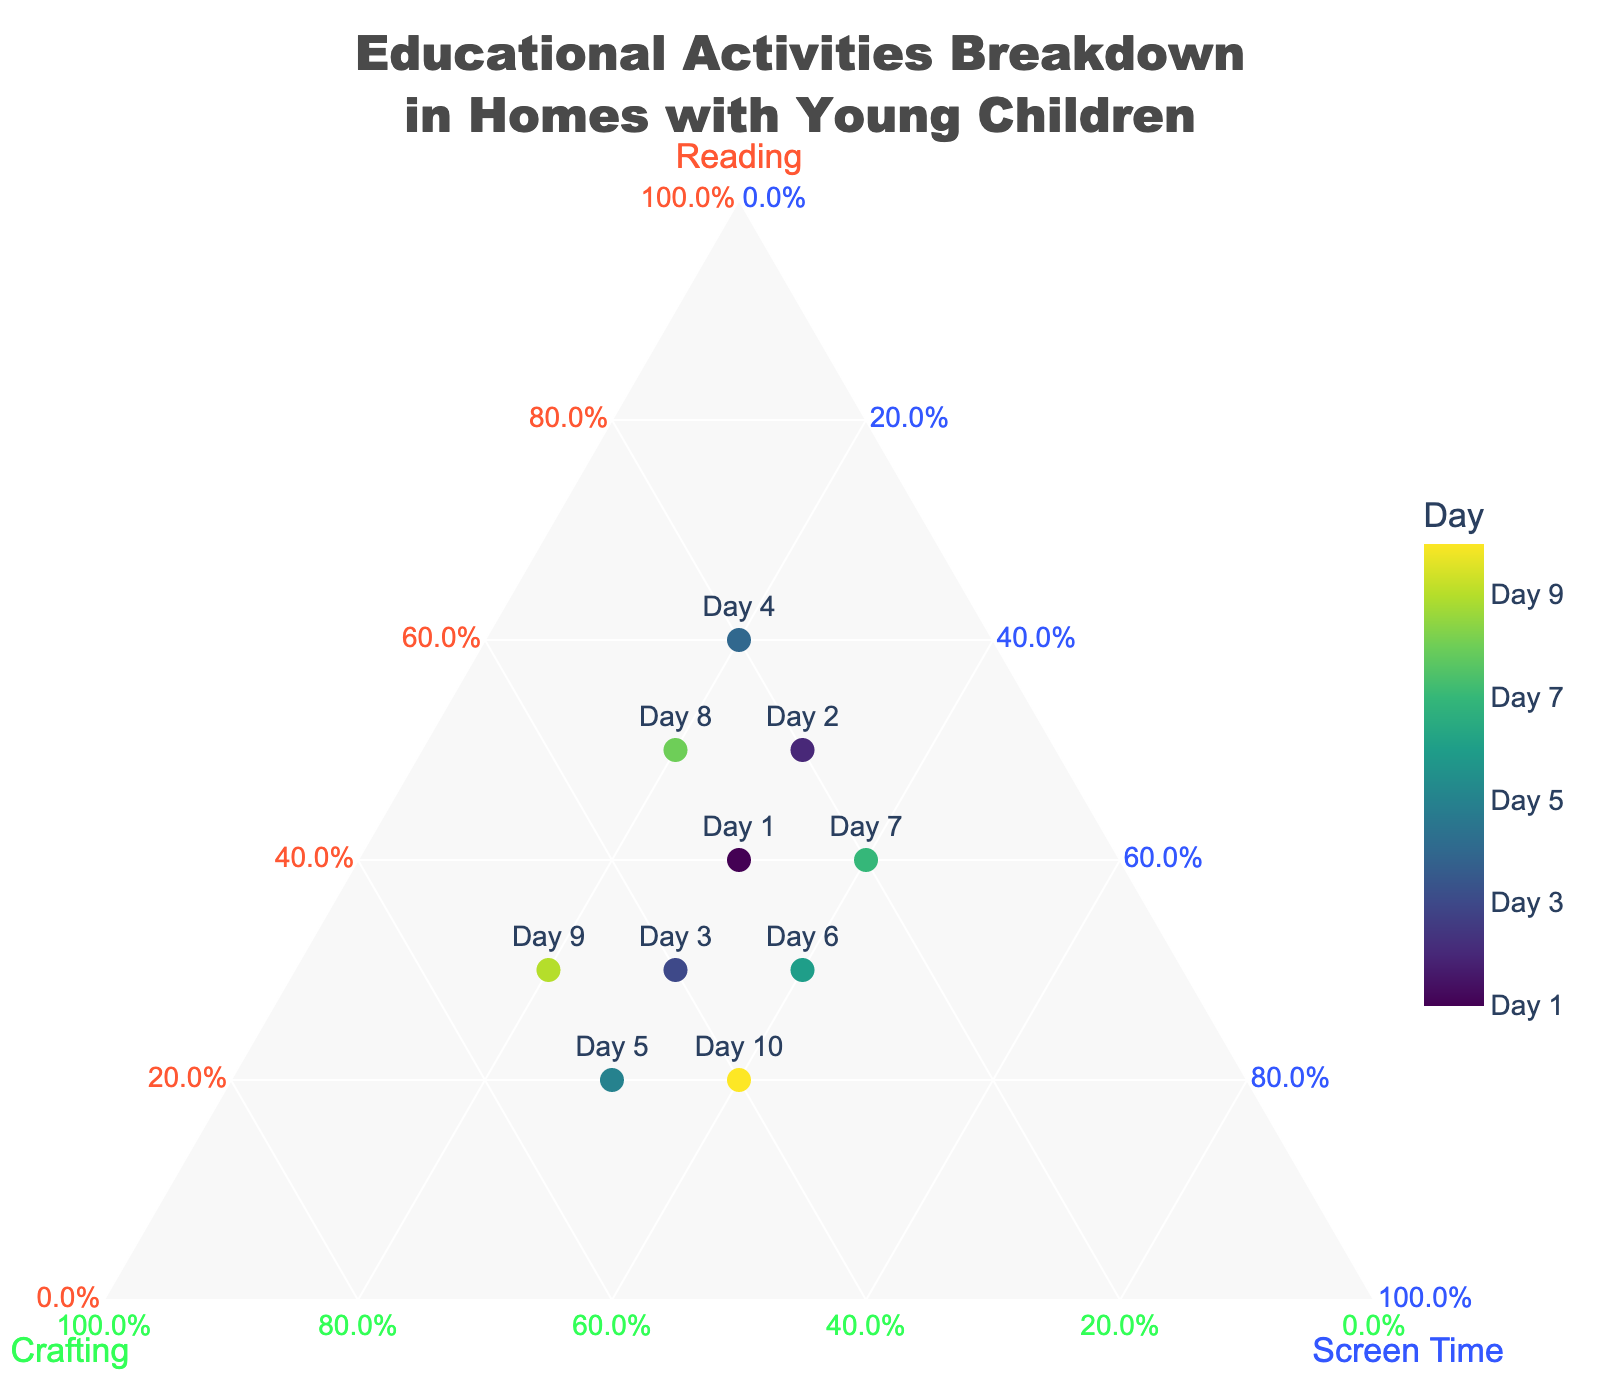What activities are included in the breakdown? The title of the chart is "Educational Activities Breakdown in Homes with Young Children," and the ternary plot axes are labeled "Reading," "Crafting," and "Screen Time." This indicates that the activities included are Reading, Crafting, and Screen Time.
Answer: Reading, Crafting, Screen Time What is the activity breakdown on Day 4? Referring to the scatter markers on the ternary plot, the point labeled "Day 4" shows the coordinates ({Reading}=0.6, {Crafting}=0.2, {Screen Time}=0.2).
Answer: Reading=0.6, Crafting=0.2, Screen Time=0.2 Which day had the highest proportion of crafting activities? Look at the values along the Crafting axis and find the highest proportion; the point labeled "Day 5" shows the highest proportion of Crafting at 0.5.
Answer: Day 5 On which days did Screen Time make up 40% of the activities? Identify the points where the Screen Time value is 0.4 on the ternary plot. This occurs on Day 6 and Day 10.
Answer: Day 6, Day 10 Which activity shows the most consistency in its proportion throughout the 10 days? Observing the spread of the points on the plot along each axis, Screen Time generally appears around 0.3-0.4 in most points, indicating it is the most consistent activity.
Answer: Screen Time What is the average proportion of Reading across all days? Sum the Reading values for all days and divide by the number of days: (0.4+0.5+0.3+0.6+0.2+0.3+0.4+0.5+0.3+0.2)/10 = 0.37.
Answer: 0.37 How many points are shown on the ternary plot? Each day is represented as a point in the chart; there are 10 days, so there are 10 points.
Answer: 10 Compare Reading and Crafting proportions on Day 2. Which one is higher? The coordinates for Day 2 are Reading=0.5, Crafting=0.2. Therefore, Reading has a higher proportion than Crafting on Day 2.
Answer: Reading Which day had the lowest proportion of reading activities? By scanning through the values along the Reading axis, the lowest reading value is 0.2 seen on Day 5 and Day 10.
Answer: Day 5, Day 10 